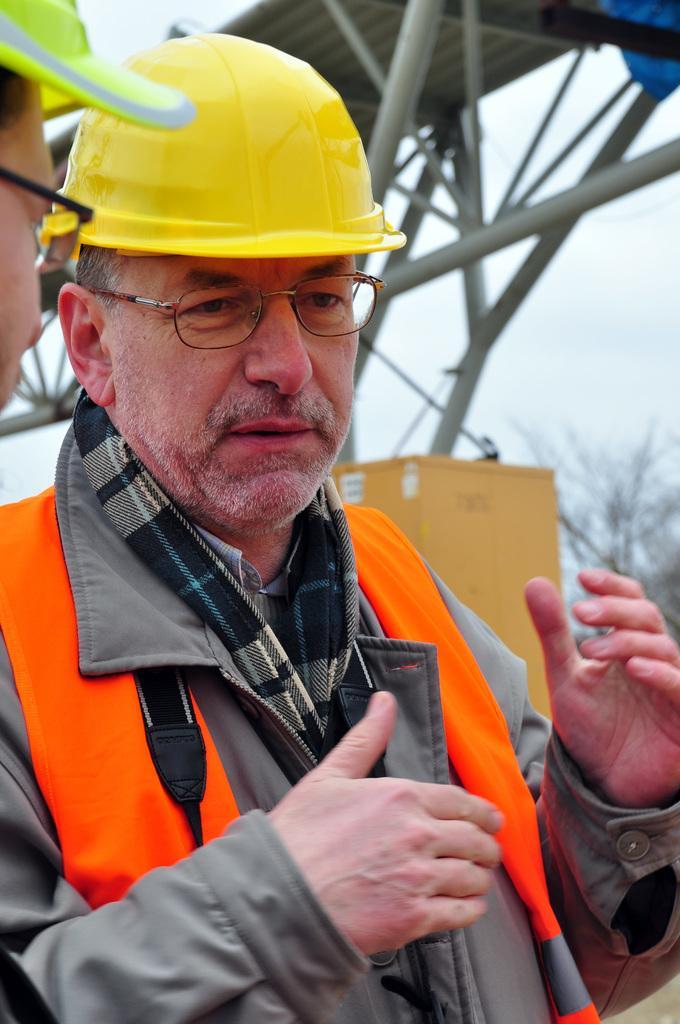Describe this image in one or two sentences. In this image we can see some people wearing helmets are standing. In the center of the image we can see a cardboard box. In the right side of the image we can see a tree. At the top of the image we can see metal poles and the sky. 